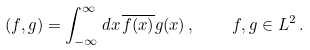Convert formula to latex. <formula><loc_0><loc_0><loc_500><loc_500>( f , g ) = \int _ { - \infty } ^ { \infty } d x \, \overline { f ( x ) } g ( x ) \, , \quad f , g \in L ^ { 2 } \, .</formula> 